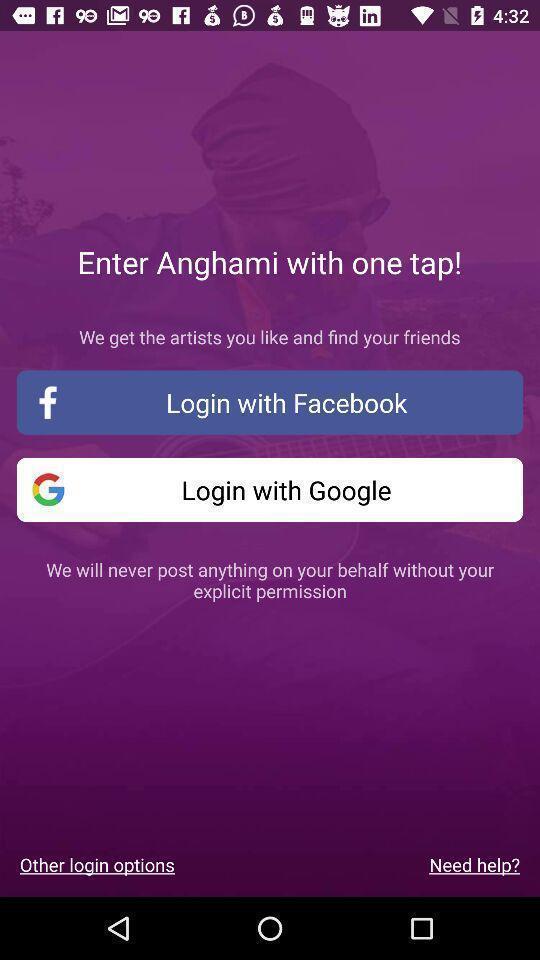Describe the key features of this screenshot. Screen displaying the login page. 